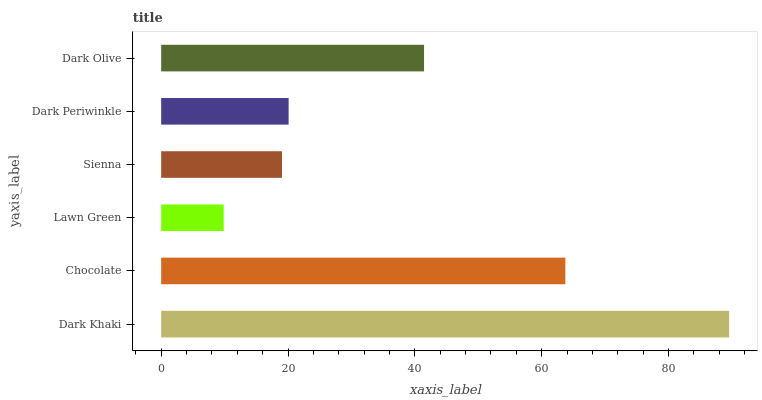Is Lawn Green the minimum?
Answer yes or no. Yes. Is Dark Khaki the maximum?
Answer yes or no. Yes. Is Chocolate the minimum?
Answer yes or no. No. Is Chocolate the maximum?
Answer yes or no. No. Is Dark Khaki greater than Chocolate?
Answer yes or no. Yes. Is Chocolate less than Dark Khaki?
Answer yes or no. Yes. Is Chocolate greater than Dark Khaki?
Answer yes or no. No. Is Dark Khaki less than Chocolate?
Answer yes or no. No. Is Dark Olive the high median?
Answer yes or no. Yes. Is Dark Periwinkle the low median?
Answer yes or no. Yes. Is Lawn Green the high median?
Answer yes or no. No. Is Dark Olive the low median?
Answer yes or no. No. 